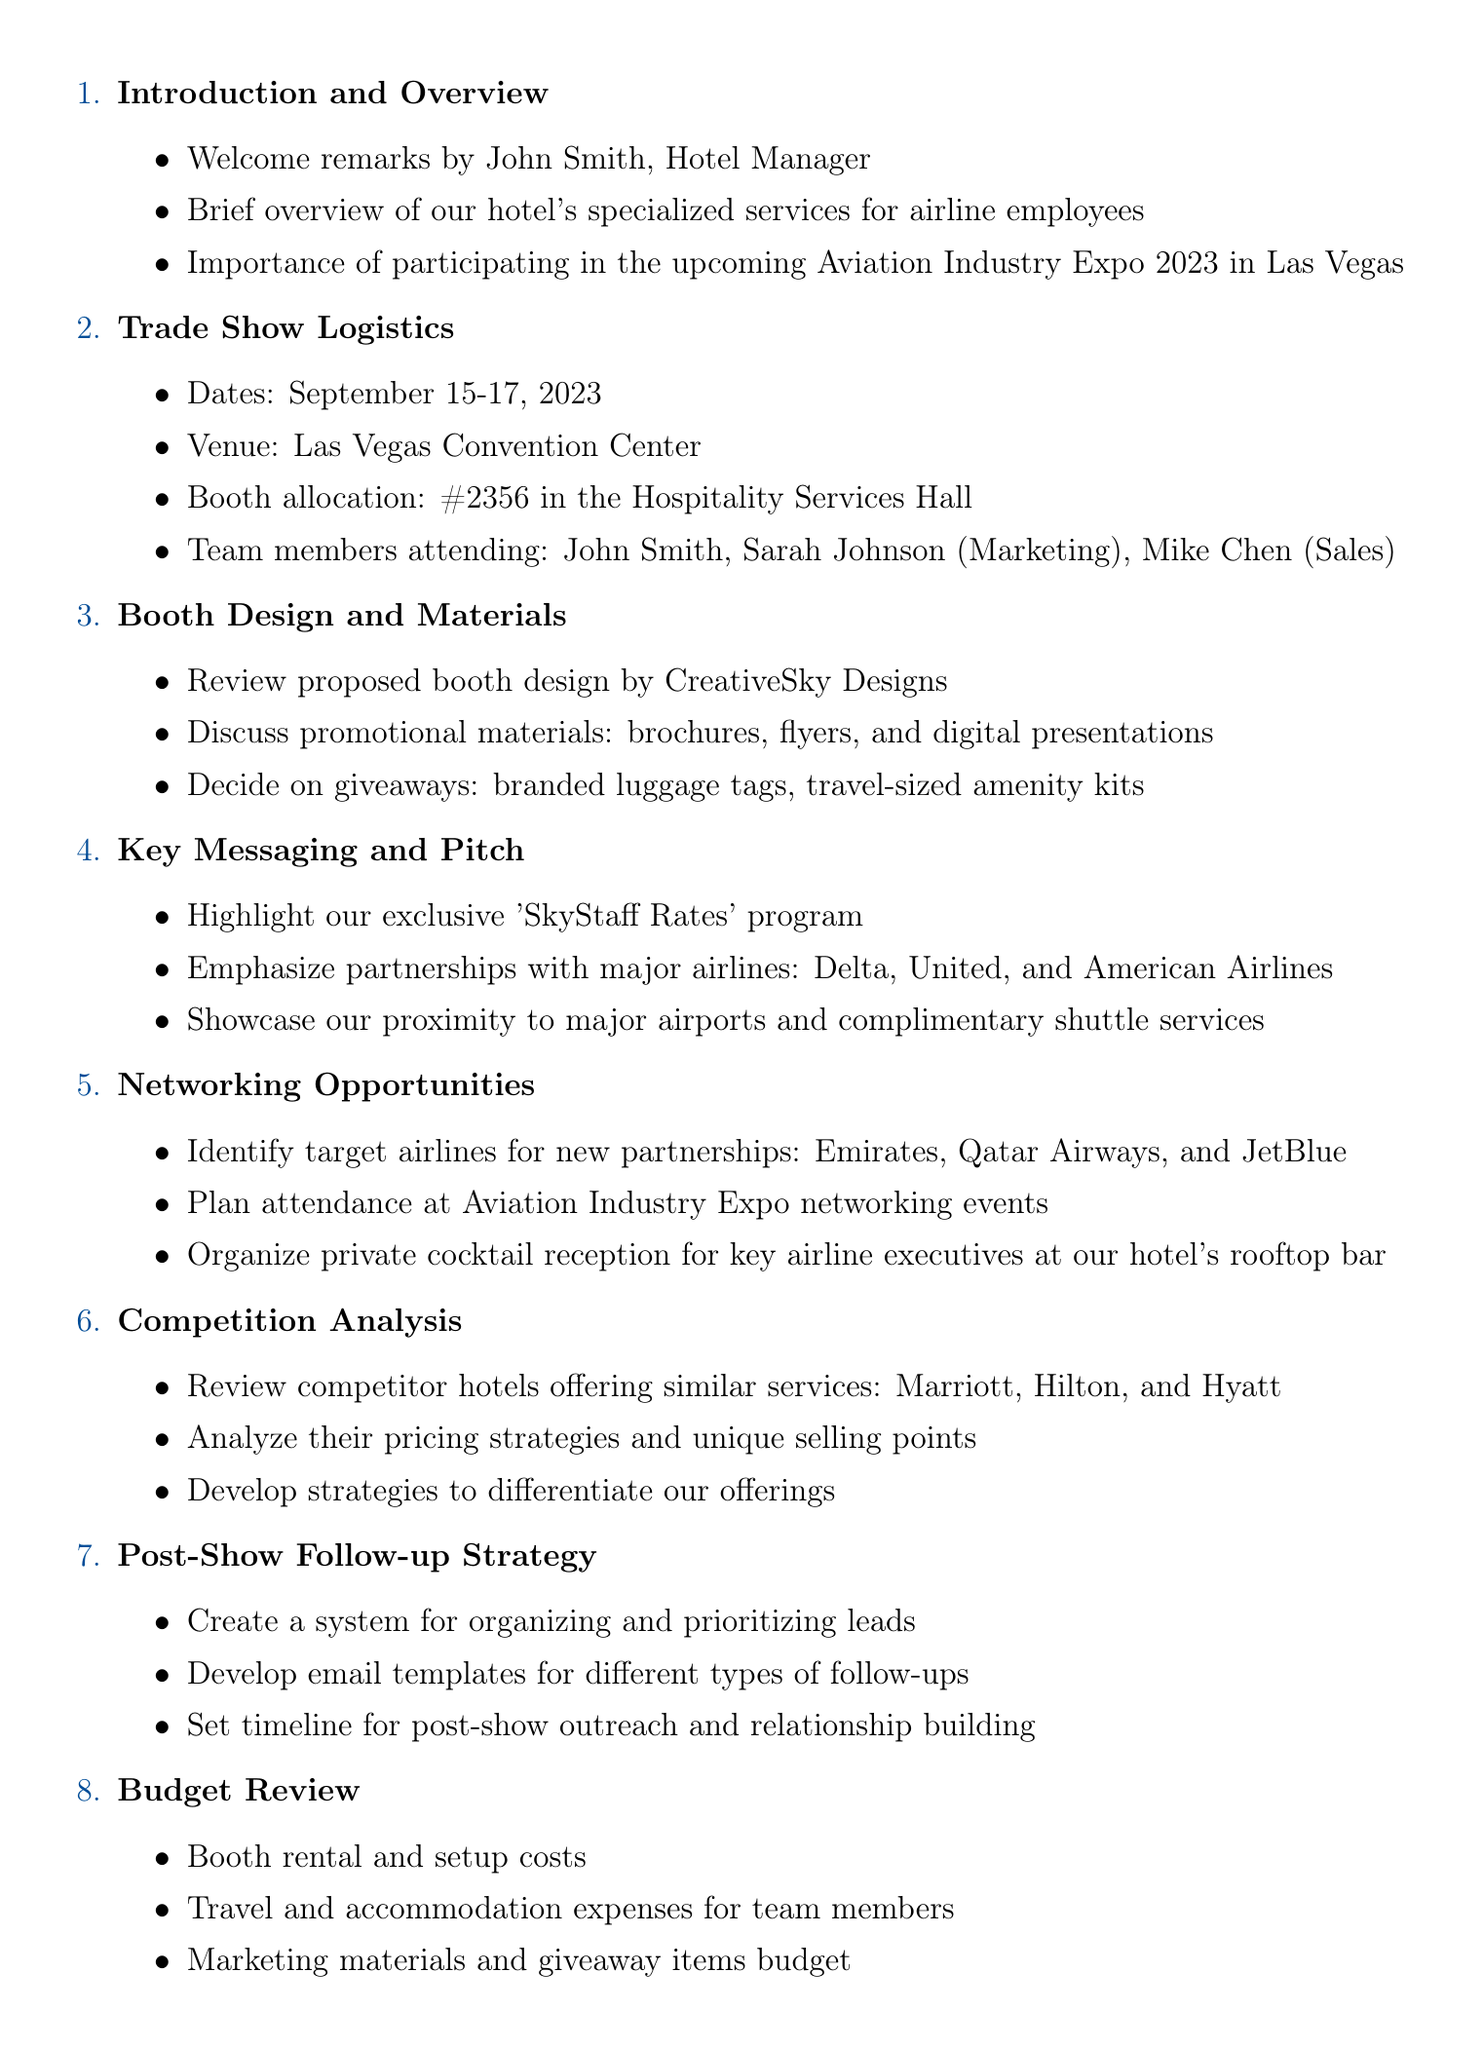what is the venue for the trade show? The venue for the trade show is mentioned in the Trade Show Logistics section.
Answer: Las Vegas Convention Center who will be attending the trade show from our hotel? The attendees are listed under Trade Show Logistics, detailing the team members.
Answer: John Smith, Sarah Johnson, Mike Chen what are the dates of the Aviation Industry Expo 2023? The dates are clearly stated in the Trade Show Logistics section of the agenda.
Answer: September 15-17, 2023 which airlines are highlighted in the key messaging? The airlines are emphasized in the Key Messaging and Pitch section.
Answer: Delta, United, American Airlines what type of reception is being organized for airline executives? The document specifies the type of reception in the Networking Opportunities section.
Answer: Private cocktail reception how many items are listed under Action Items and Next Steps? The number of items is identified in the Action Items and Next Steps section.
Answer: Three which competitors are mentioned for analysis? Competitors are listed in the Competition Analysis section, naming specific hotels.
Answer: Marriott, Hilton, Hyatt what is the purpose of the post-show follow-up strategy? The purpose can be inferred from the details within the Post-Show Follow-up Strategy section.
Answer: Organizing and prioritizing leads 